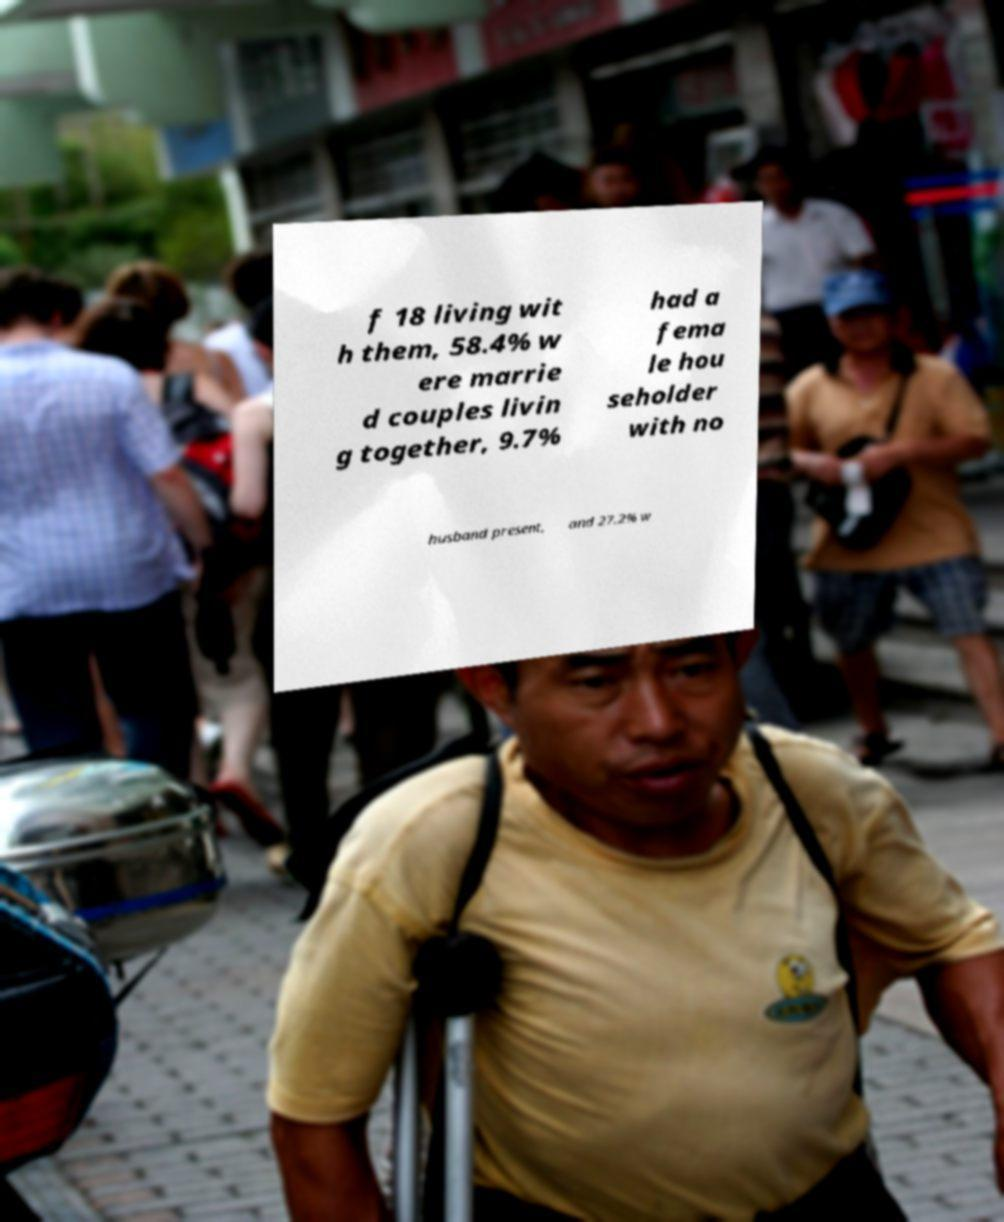Please identify and transcribe the text found in this image. f 18 living wit h them, 58.4% w ere marrie d couples livin g together, 9.7% had a fema le hou seholder with no husband present, and 27.2% w 